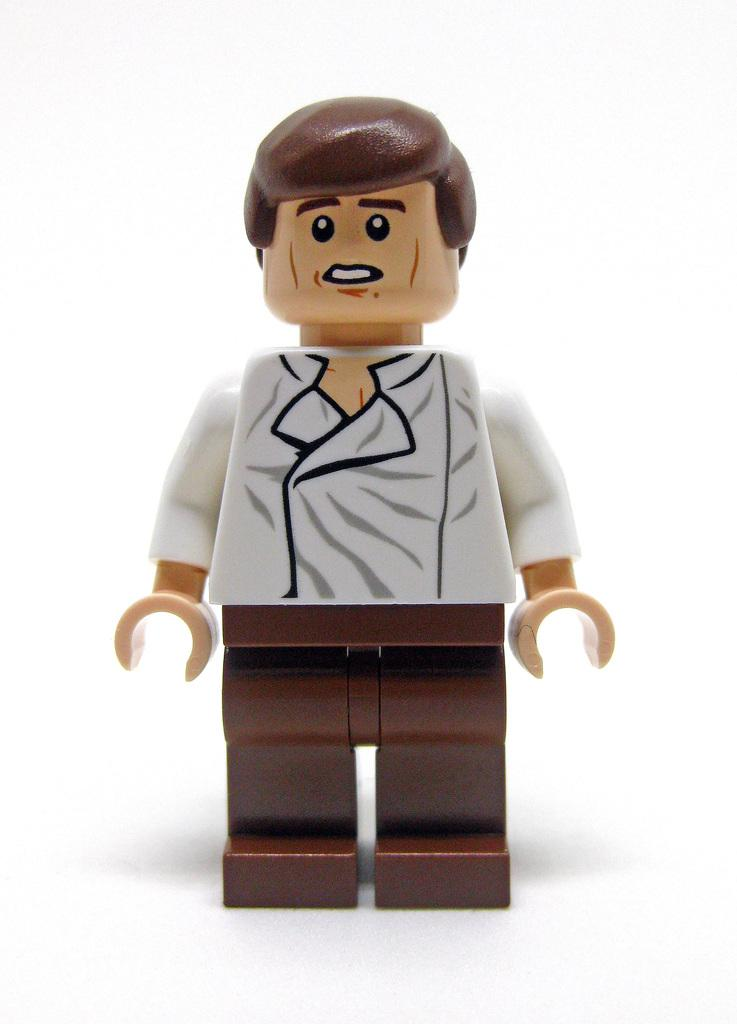What is the main object in the image? There is a toy in the image. What type of toy is it? The toy is of a person. Where is the toy positioned in the image? The toy is standing on a platform. What type of wood is used to make the cannon in the image? There is no cannon present in the image; it features a toy of a person standing on a platform. 